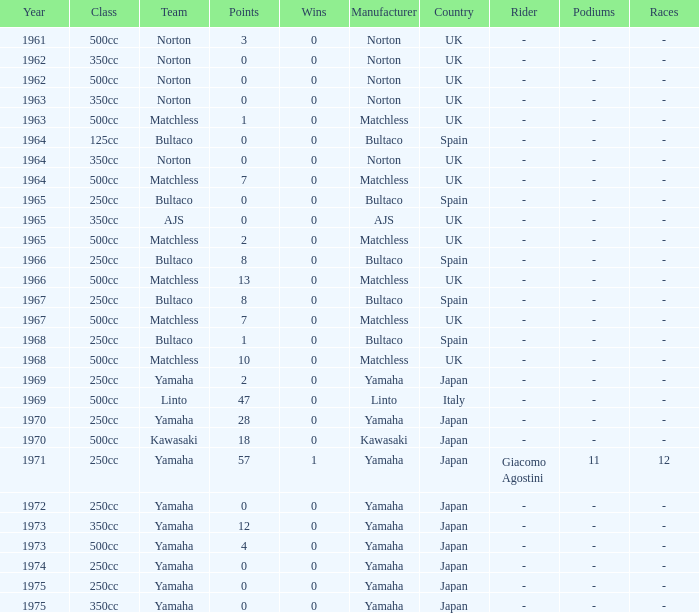What is the average wins in 250cc class for Bultaco with 8 points later than 1966? 0.0. 